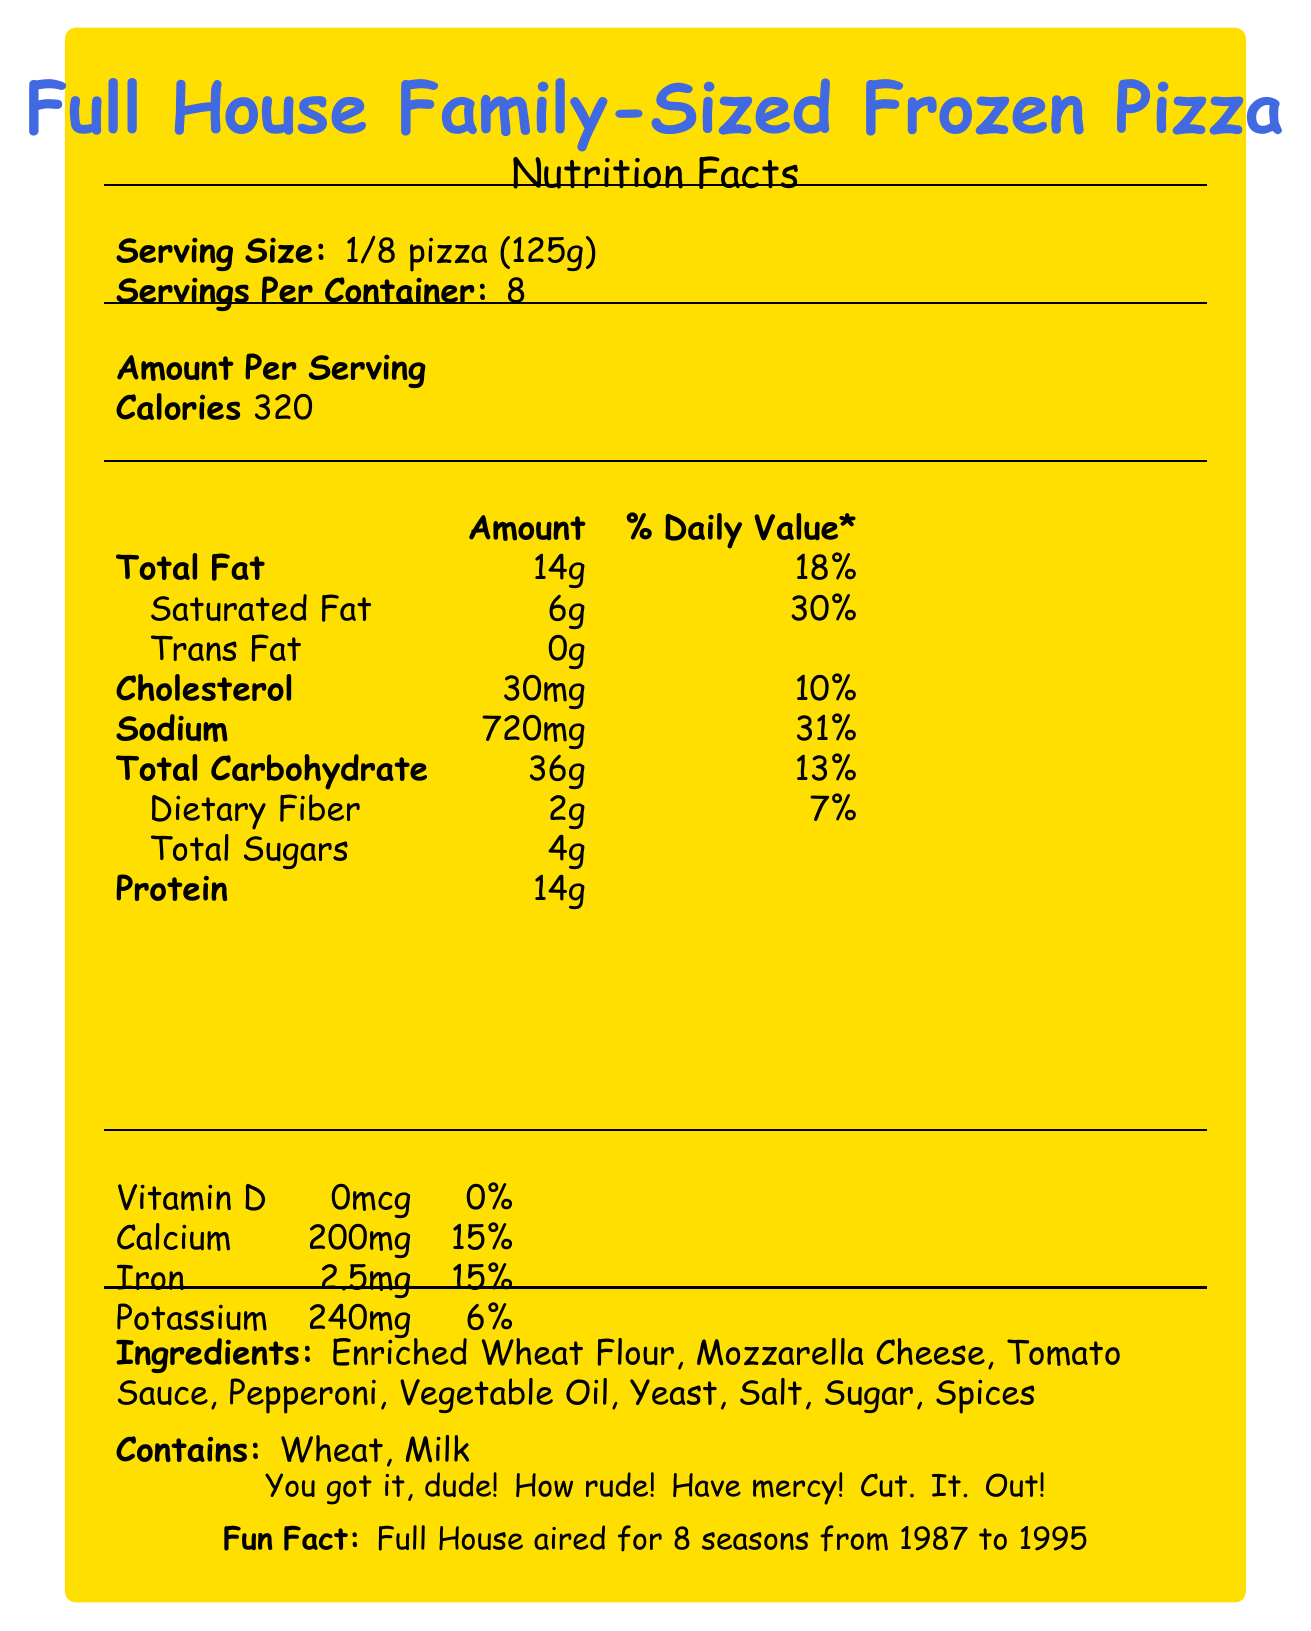who is the manufacturer of Full House Family-Sized Frozen Pizza? The document clearly states that the manufacturer of the Full House Family-Sized Frozen Pizza is Tanner's Tasty Treats, Inc.
Answer: Tanner's Tasty Treats, Inc. what is the serving size of the pizza? According to the document, the serving size for the Full House Family-Sized Frozen Pizza is 1/8 of the pizza, which weighs 125 grams.
Answer: 1/8 pizza (125g) how many calories are in one serving of the pizza? The nutrition facts section of the document states that one serving of the pizza contains 320 calories.
Answer: 320 calories what is the website for the Full House Family-Sized Frozen Pizza? The document lists the website for the Full House Family-Sized Frozen Pizza as www.fullhousepizza.com.
Answer: www.fullhousepizza.com which vitamins are listed in the nutrition facts, and what are their daily values? The document lists the vitamins and their daily values as follows: Vitamin D has 0%, Calcium has 15%, Iron has 15%, and Potassium has 6%.
Answer: Vitamin D: 0%, Calcium: 15%, Iron: 15%, Potassium: 6% how many servings are in one container of Full House Family-Sized Frozen Pizza? A) 6 B) 8 C) 10 D) 12 The document states that there are 8 servings per container.
Answer: B how much saturated fat is in one serving of the pizza? A) 4g B) 6g C) 8g D) 10g According to the nutrition facts, one serving of the pizza contains 6 grams of saturated fat.
Answer: B does the pizza contain any allergens? The document indicates that the pizza contains wheat and milk, which are common allergens.
Answer: Yes describe the main idea of the document. This summary encapsulates the comprehensive nature of the document, focusing on the nutrition information, ingredients, allergens, additional fun facts, and cooking/storage instructions associated with the product.
Answer: The document provides detailed nutrition facts, ingredients, allergens, and cooking instructions for Full House Family-Sized Frozen Pizza, along with catchphrases and trivia from the "Full House" TV show. can you determine the exact weight of the whole pizza from the document? Each serving is 125g, and there are 8 servings per container. Therefore, the entire pizza weighs 1000g (125g × 8).
Answer: Yes who sings the theme song of the show "Full House"? The document mentions that the theme song is "Everywhere You Look" by Jesse Frederick, but it does not provide details on who sings it.
Answer: Not enough information 